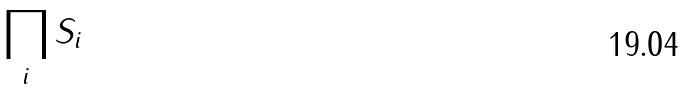<formula> <loc_0><loc_0><loc_500><loc_500>\prod _ { i } S _ { i }</formula> 